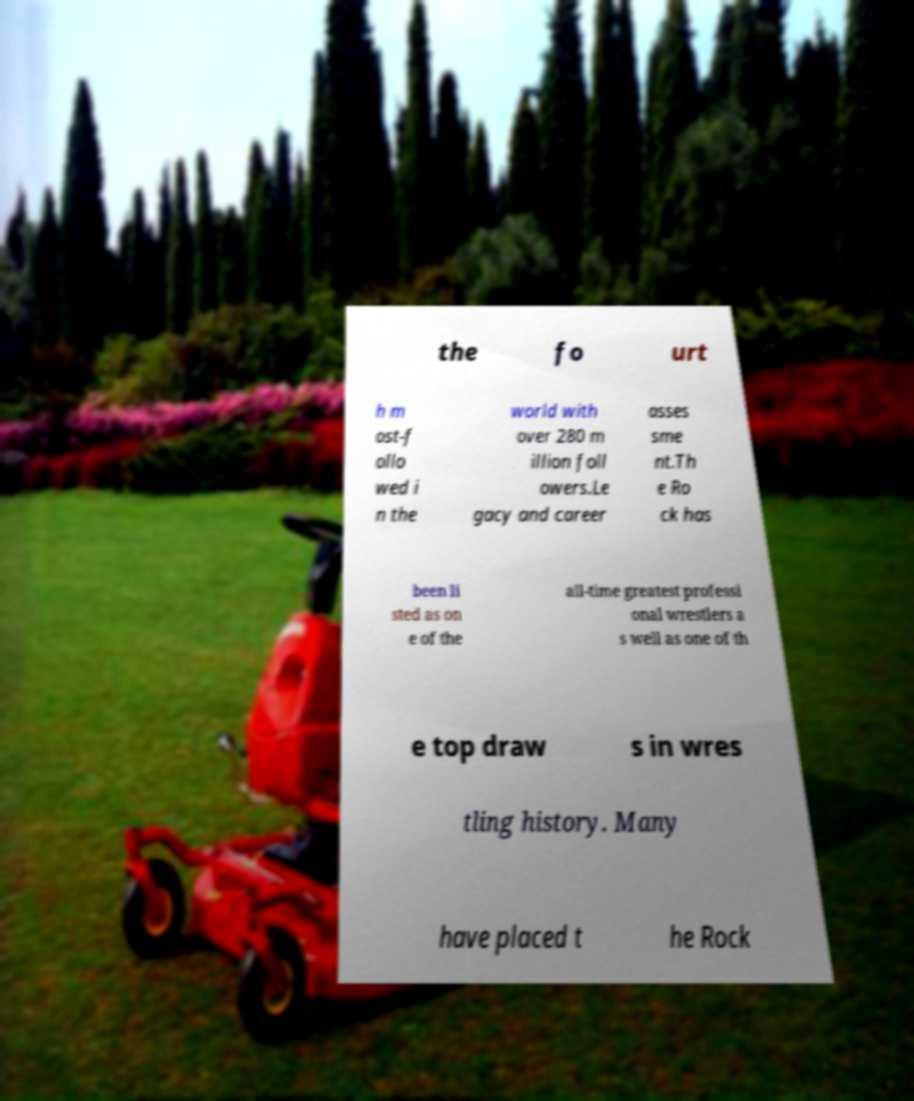What messages or text are displayed in this image? I need them in a readable, typed format. the fo urt h m ost-f ollo wed i n the world with over 280 m illion foll owers.Le gacy and career asses sme nt.Th e Ro ck has been li sted as on e of the all-time greatest professi onal wrestlers a s well as one of th e top draw s in wres tling history. Many have placed t he Rock 